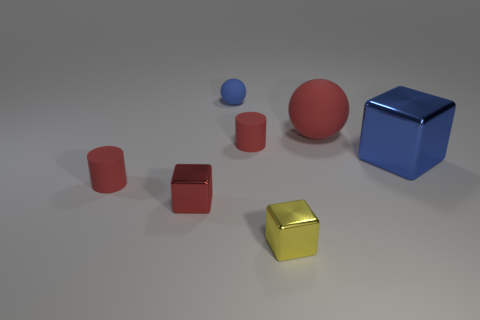Add 3 tiny metal things. How many objects exist? 10 Subtract all cubes. How many objects are left? 4 Add 6 red metal objects. How many red metal objects exist? 7 Subtract 0 purple spheres. How many objects are left? 7 Subtract all small yellow shiny blocks. Subtract all matte balls. How many objects are left? 4 Add 6 big cubes. How many big cubes are left? 7 